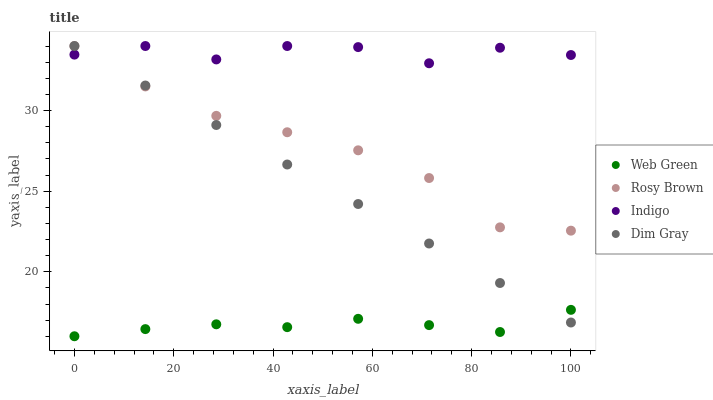Does Web Green have the minimum area under the curve?
Answer yes or no. Yes. Does Indigo have the maximum area under the curve?
Answer yes or no. Yes. Does Rosy Brown have the minimum area under the curve?
Answer yes or no. No. Does Rosy Brown have the maximum area under the curve?
Answer yes or no. No. Is Dim Gray the smoothest?
Answer yes or no. Yes. Is Indigo the roughest?
Answer yes or no. Yes. Is Rosy Brown the smoothest?
Answer yes or no. No. Is Rosy Brown the roughest?
Answer yes or no. No. Does Web Green have the lowest value?
Answer yes or no. Yes. Does Rosy Brown have the lowest value?
Answer yes or no. No. Does Indigo have the highest value?
Answer yes or no. Yes. Does Web Green have the highest value?
Answer yes or no. No. Is Web Green less than Indigo?
Answer yes or no. Yes. Is Indigo greater than Web Green?
Answer yes or no. Yes. Does Dim Gray intersect Rosy Brown?
Answer yes or no. Yes. Is Dim Gray less than Rosy Brown?
Answer yes or no. No. Is Dim Gray greater than Rosy Brown?
Answer yes or no. No. Does Web Green intersect Indigo?
Answer yes or no. No. 